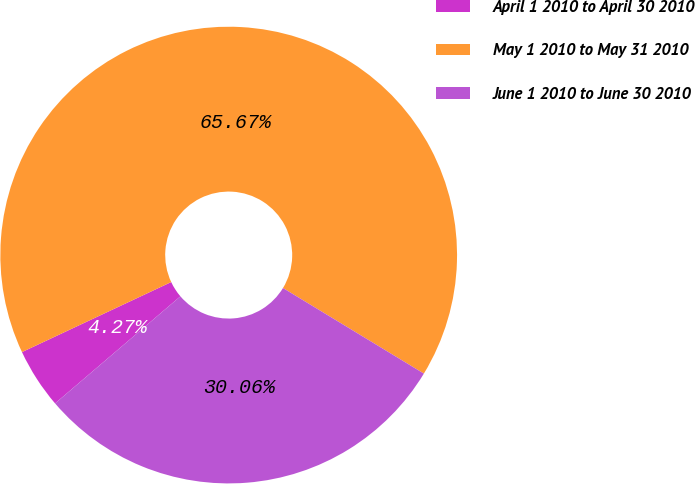<chart> <loc_0><loc_0><loc_500><loc_500><pie_chart><fcel>April 1 2010 to April 30 2010<fcel>May 1 2010 to May 31 2010<fcel>June 1 2010 to June 30 2010<nl><fcel>4.27%<fcel>65.67%<fcel>30.06%<nl></chart> 